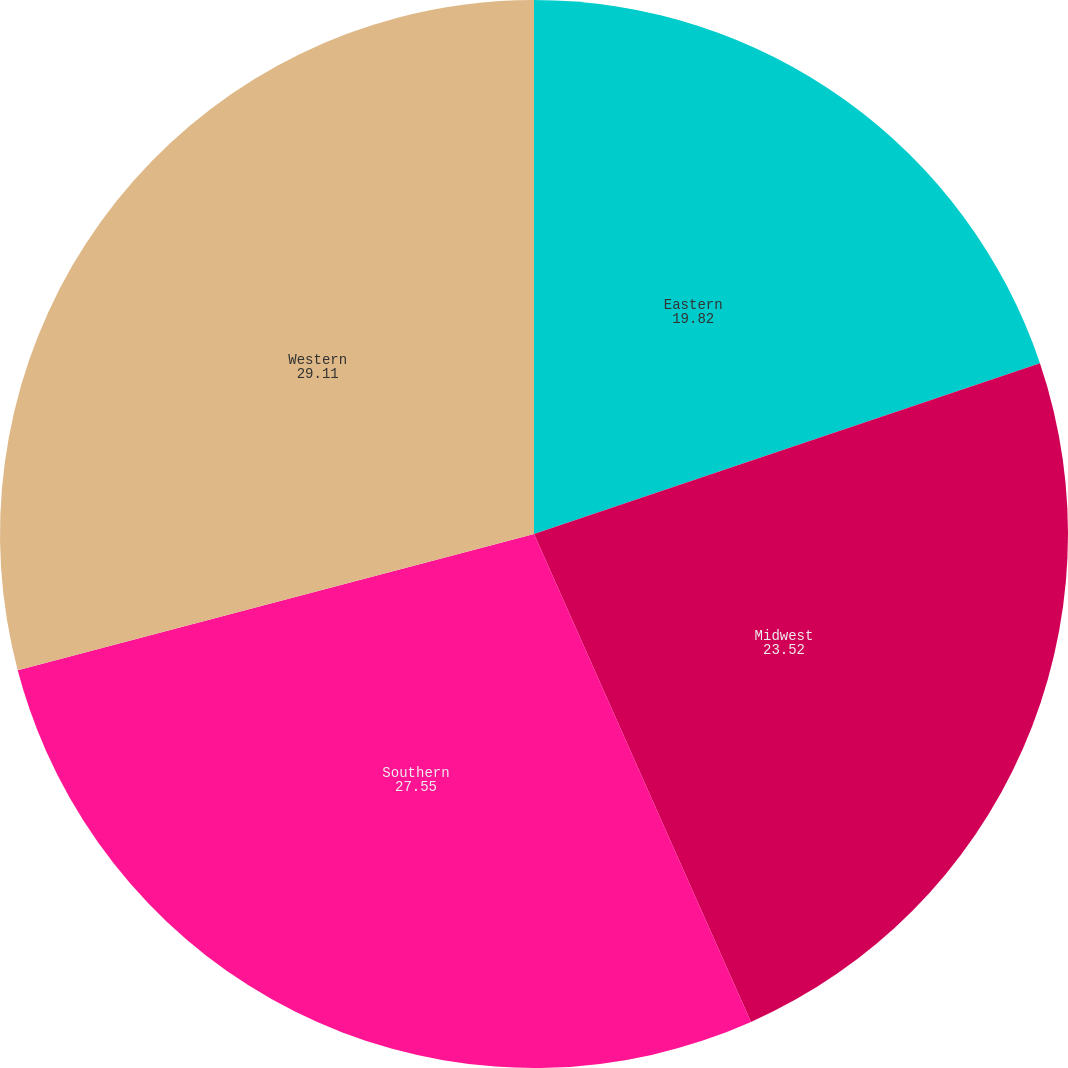Convert chart. <chart><loc_0><loc_0><loc_500><loc_500><pie_chart><fcel>Eastern<fcel>Midwest<fcel>Southern<fcel>Western<nl><fcel>19.82%<fcel>23.52%<fcel>27.55%<fcel>29.11%<nl></chart> 